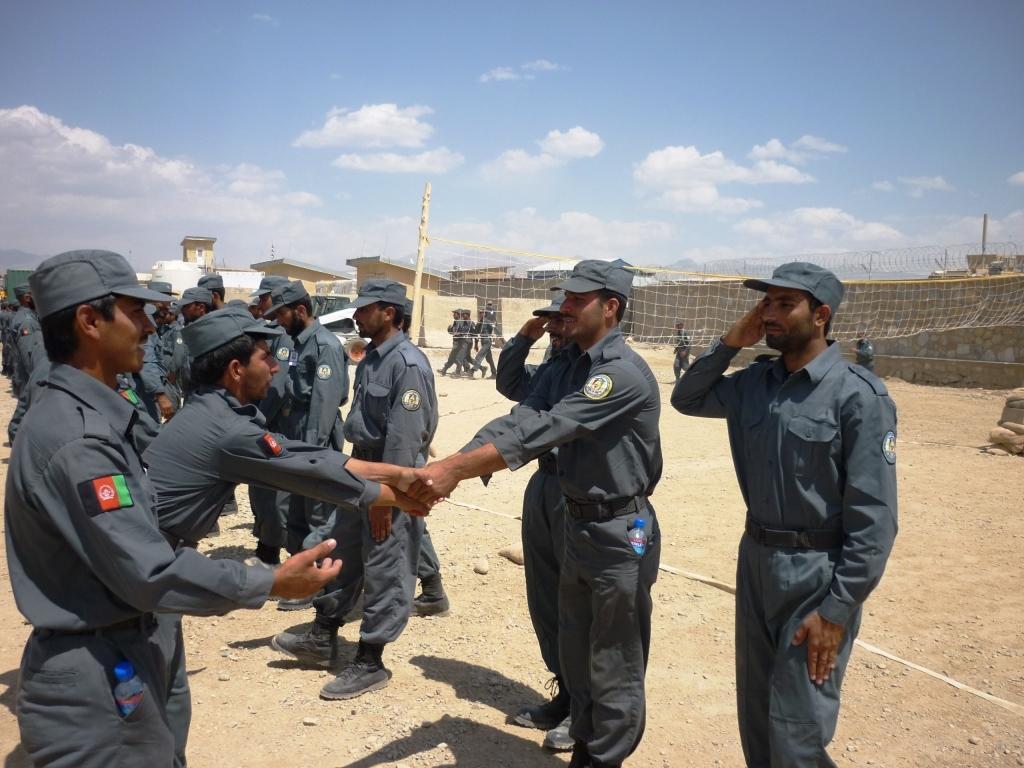Could you give a brief overview of what you see in this image? A group of people are standing, they wore grey color dresses, caps. On the right side there is a net. At the top it's a sunny sky. 